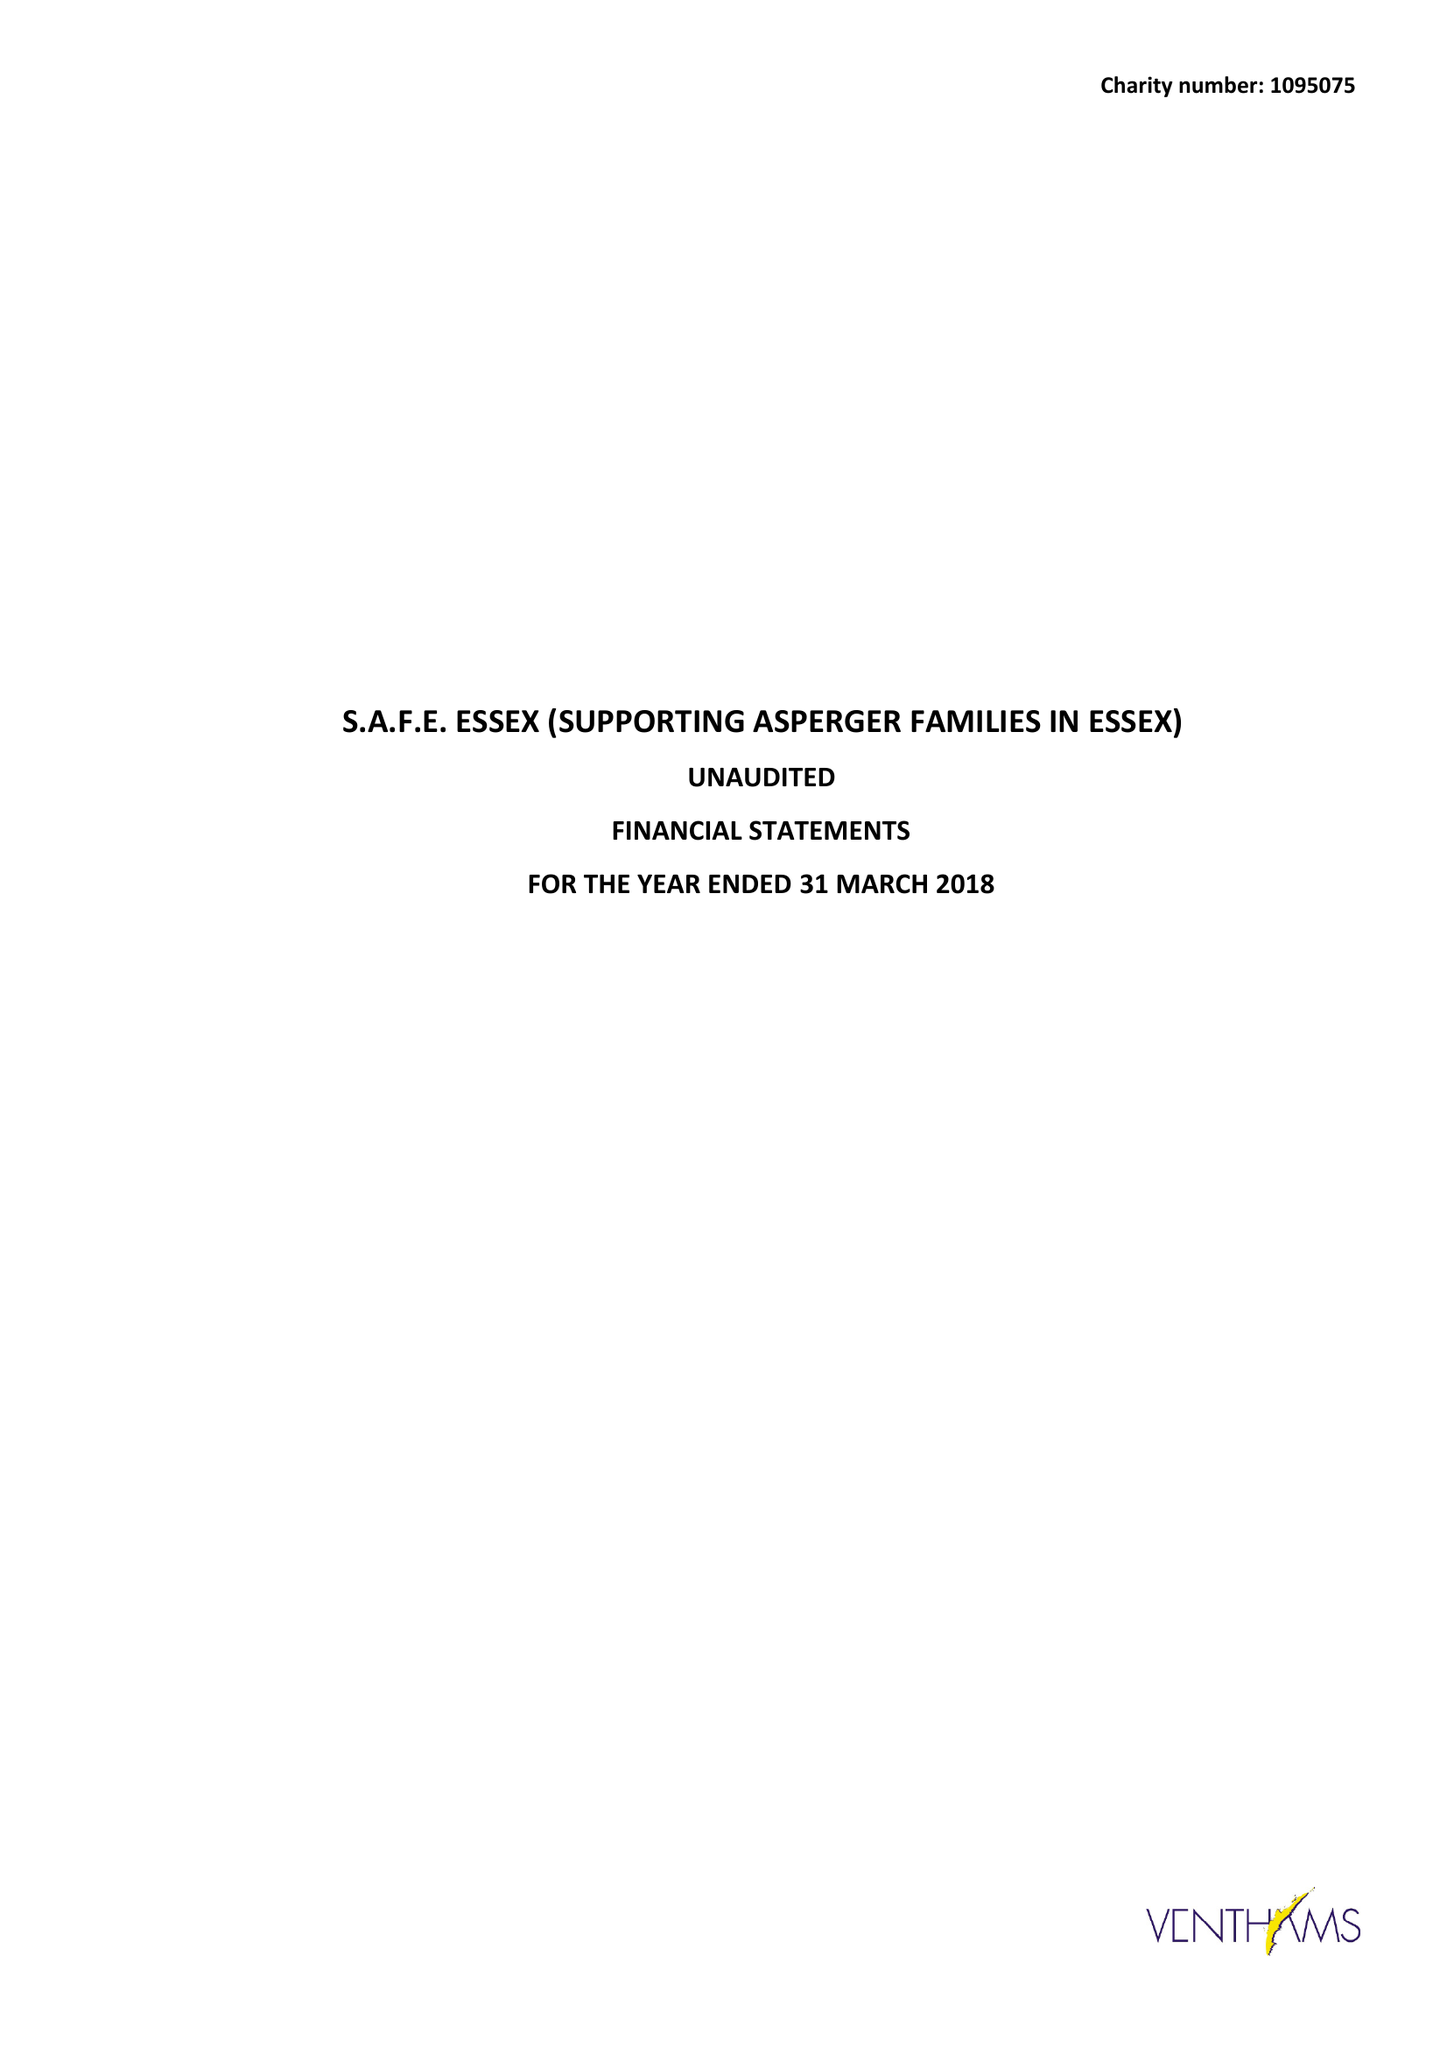What is the value for the spending_annually_in_british_pounds?
Answer the question using a single word or phrase. 40232.00 